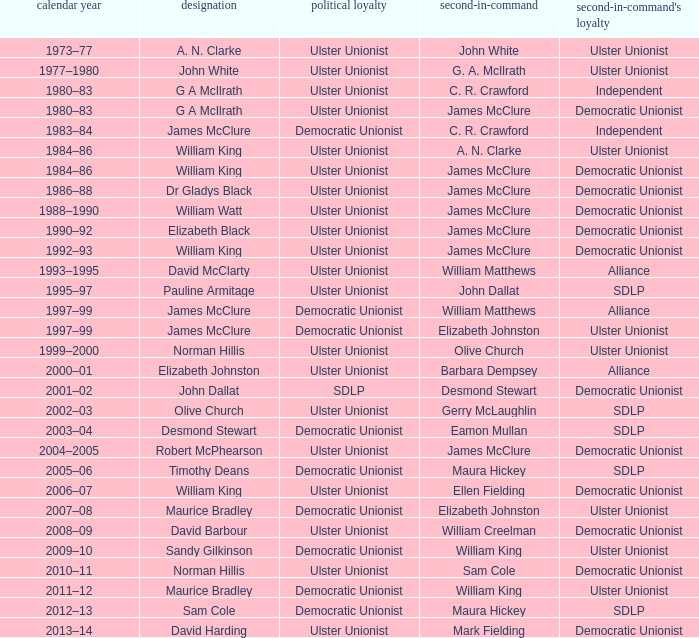What is the name of the deputy in 1992–93? James McClure. 